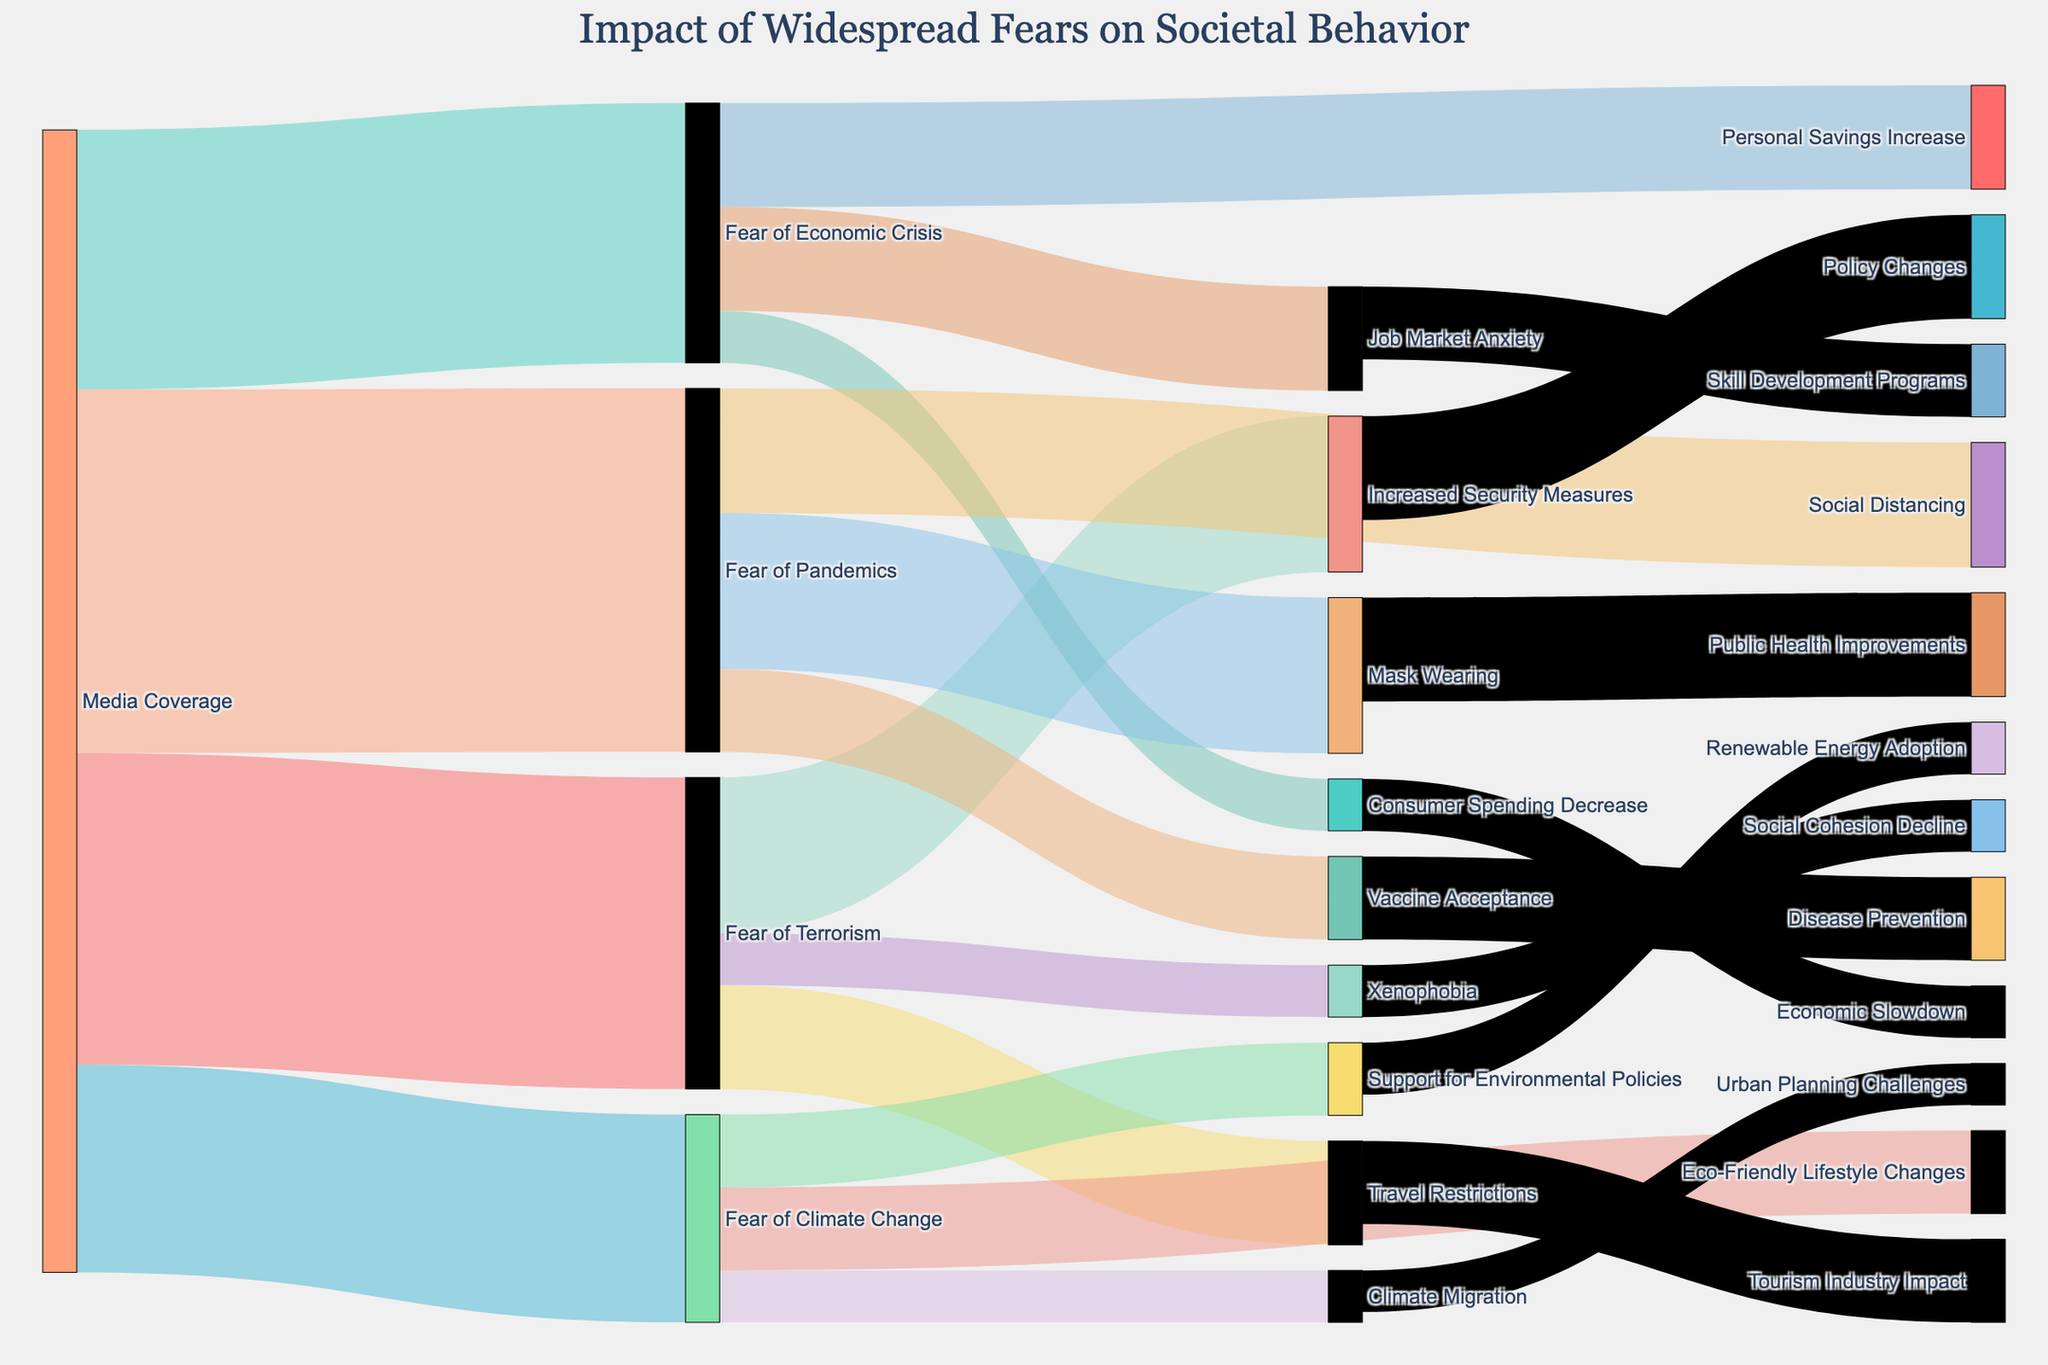What is the title of the Sankey Diagram? The title of the Sankey Diagram is displayed at the top center of the figure.
Answer: Impact of Widespread Fears on Societal Behavior What is the primary impact of 'Fear of Pandemics'? Examine the arrows stemming from 'Fear of Pandemics' and note the one with the highest value.
Answer: Mask Wearing How many behavioral impacts are linked to 'Fear of Climate Change'? Count the number of arrows flowing out from 'Fear of Climate Change' to various targets.
Answer: Three Which societal fear has the highest value due to 'Media Coverage'? Compare the values of arrows originating from 'Media Coverage' to different fears and identify the highest value.
Answer: Fear of Pandemics What is the combined value of 'Increased Security Measures' and 'Travel Restrictions' caused by 'Fear of Terrorism'? Add the values of the arrows from 'Fear of Terrorism' to 'Increased Security Measures' (15) and 'Travel Restrictions' (10).
Answer: 25 Which target node is affected by 'Xenophobia', and what is its value? Trace the arrow from 'Xenophobia' to identify its target, and note the value.
Answer: Social Cohesion Decline, 5 What is the proportion of the value of 'Support for Environmental Policies' to the sum of all impacts of 'Fear of Climate Change'? Divide the value of 'Support for Environmental Policies' (7) by the total sum of impacts from 'Fear of Climate Change' (8 + 7 + 5). 7/20 = 0.35
Answer: 0.35 How many arrows flow out of 'Fear of Economic Crisis'? Count the number of arrows stemming from 'Fear of Economic Crisis' to other nodes.
Answer: Three Which fear results in the most diverse set of behavioral impacts? Count and compare the number of different target nodes that each 'Fear' connects to.
Answer: Fear of Pandemics How does 'Job Market Anxiety' link to further societal outcomes? Trace the arrow from 'Job Market Anxiety' to its subsequent impact(s).
Answer: Skill Development Programs 